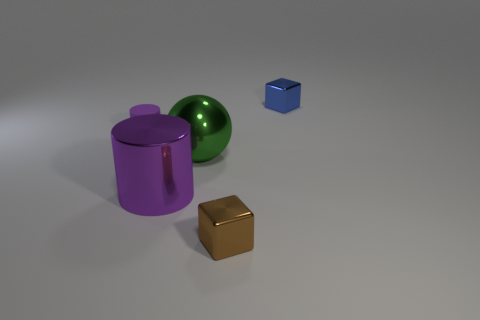Add 2 tiny rubber cylinders. How many objects exist? 7 Subtract all cubes. How many objects are left? 3 Add 2 small brown metal cubes. How many small brown metal cubes are left? 3 Add 4 cubes. How many cubes exist? 6 Subtract 0 gray balls. How many objects are left? 5 Subtract all small red cylinders. Subtract all brown objects. How many objects are left? 4 